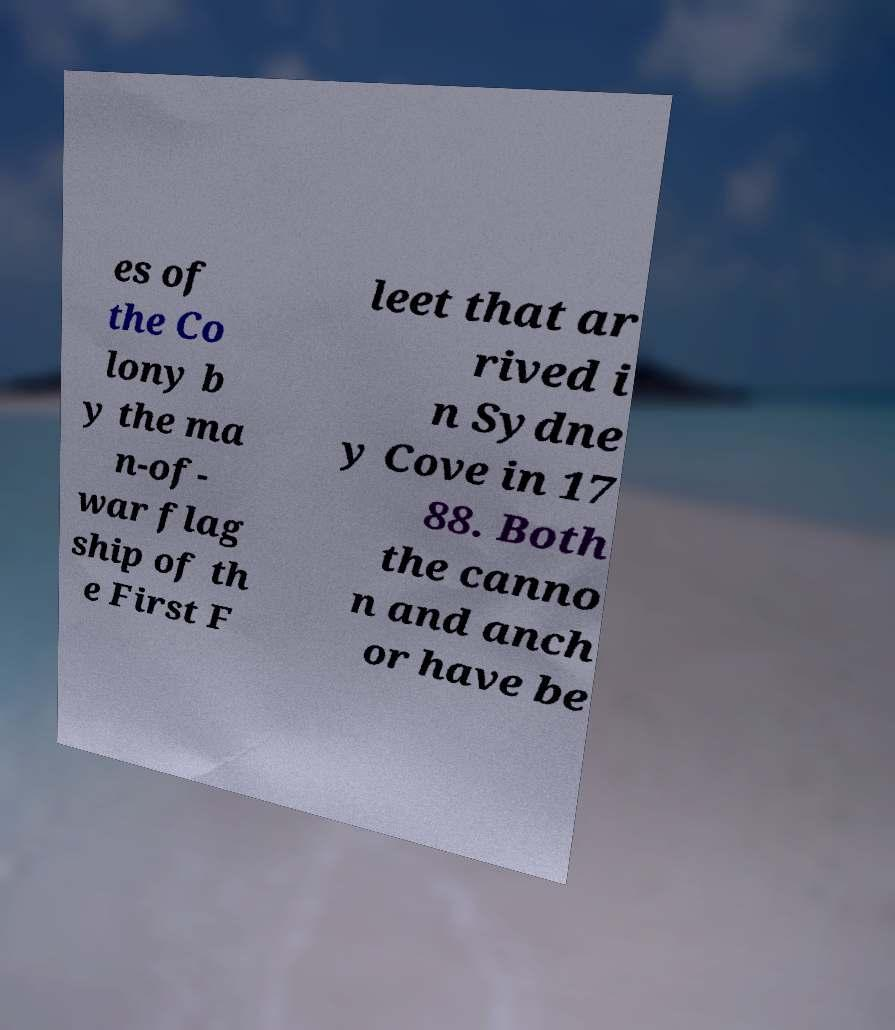There's text embedded in this image that I need extracted. Can you transcribe it verbatim? es of the Co lony b y the ma n-of- war flag ship of th e First F leet that ar rived i n Sydne y Cove in 17 88. Both the canno n and anch or have be 